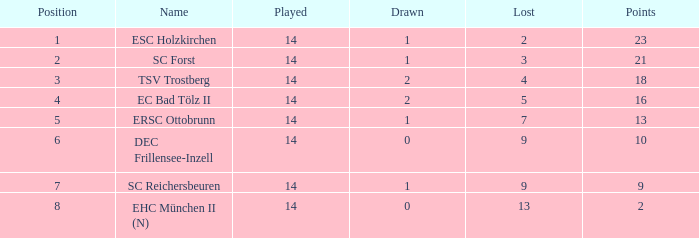Which Lost is the lowest one that has a Name of esc holzkirchen, and Played smaller than 14? None. 